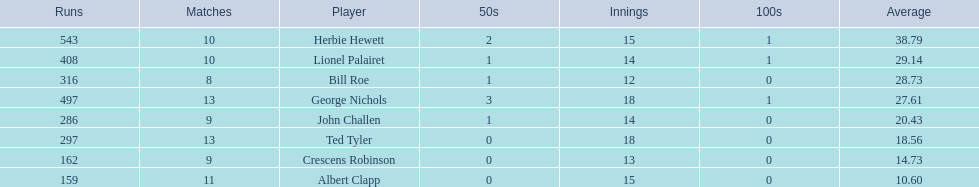Who are the players in somerset county cricket club in 1890? Herbie Hewett, Lionel Palairet, Bill Roe, George Nichols, John Challen, Ted Tyler, Crescens Robinson, Albert Clapp. Who is the only player to play less than 13 innings? Bill Roe. 